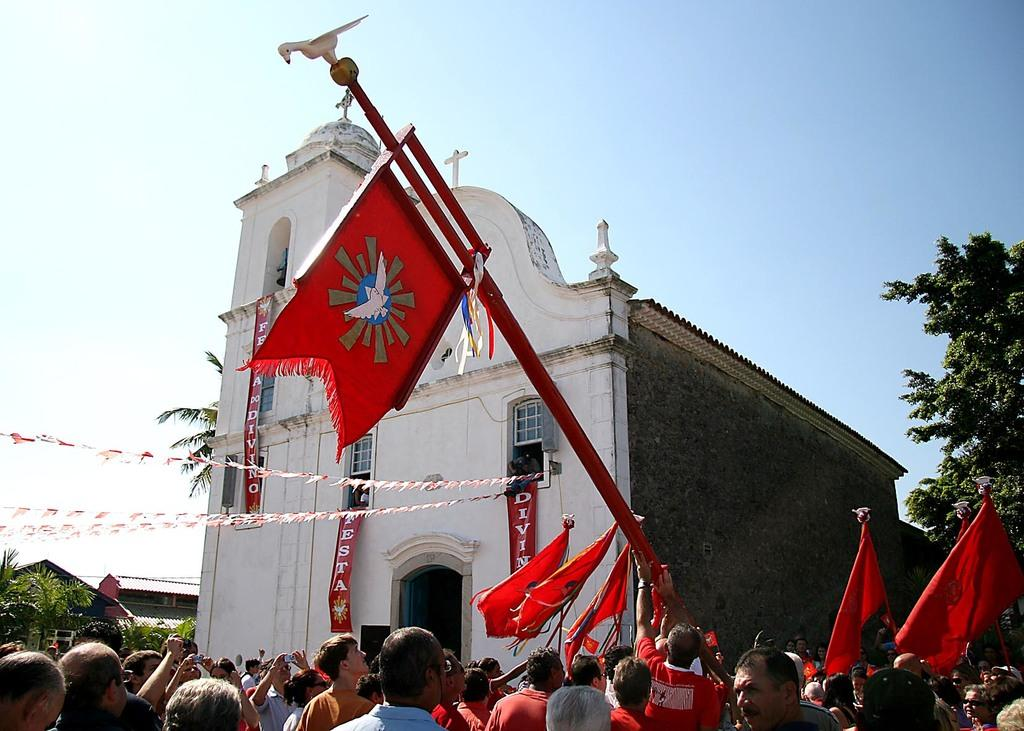What are the people in the image holding? The people in the image are holding flags. What type of structures can be seen in the image? There are houses in the image. What type of vegetation is visible in the image? There are trees in the image. Can you see a snake slithering through the trees in the image? There is no snake present in the image. Is there a bike visible among the people holding flags in the image? There is no bike present in the image. 